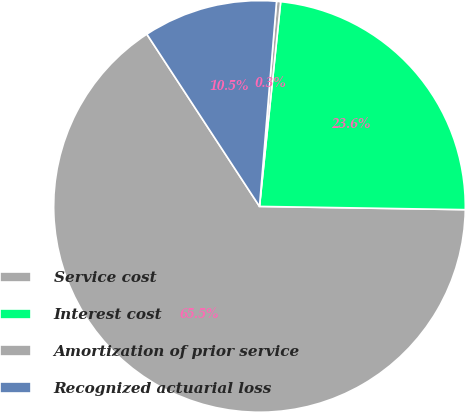Convert chart. <chart><loc_0><loc_0><loc_500><loc_500><pie_chart><fcel>Service cost<fcel>Interest cost<fcel>Amortization of prior service<fcel>Recognized actuarial loss<nl><fcel>65.53%<fcel>23.61%<fcel>0.32%<fcel>10.54%<nl></chart> 